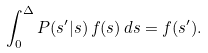Convert formula to latex. <formula><loc_0><loc_0><loc_500><loc_500>\int _ { 0 } ^ { \Delta } P ( s ^ { \prime } | s ) \, f ( s ) \, d s = f ( s ^ { \prime } ) .</formula> 